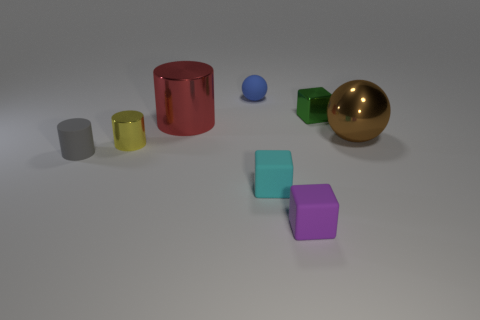How many objects are tiny shiny objects that are left of the tiny green metal cube or large green things?
Give a very brief answer. 1. Are there any brown things that have the same size as the brown metallic sphere?
Ensure brevity in your answer.  No. Are there any tiny metallic cylinders that are on the left side of the small matte object left of the blue matte ball?
Offer a very short reply. No. What number of blocks are brown things or big red shiny objects?
Keep it short and to the point. 0. Is there a small purple metal thing that has the same shape as the yellow shiny thing?
Make the answer very short. No. There is a yellow object; what shape is it?
Provide a short and direct response. Cylinder. What number of objects are big cyan balls or purple matte things?
Give a very brief answer. 1. Does the matte thing that is on the left side of the small yellow object have the same size as the sphere in front of the tiny blue sphere?
Provide a short and direct response. No. How many other things are the same material as the tiny purple object?
Your answer should be very brief. 3. Are there more cyan matte objects that are behind the tiny cyan matte cube than small blocks left of the tiny blue thing?
Provide a succinct answer. No. 